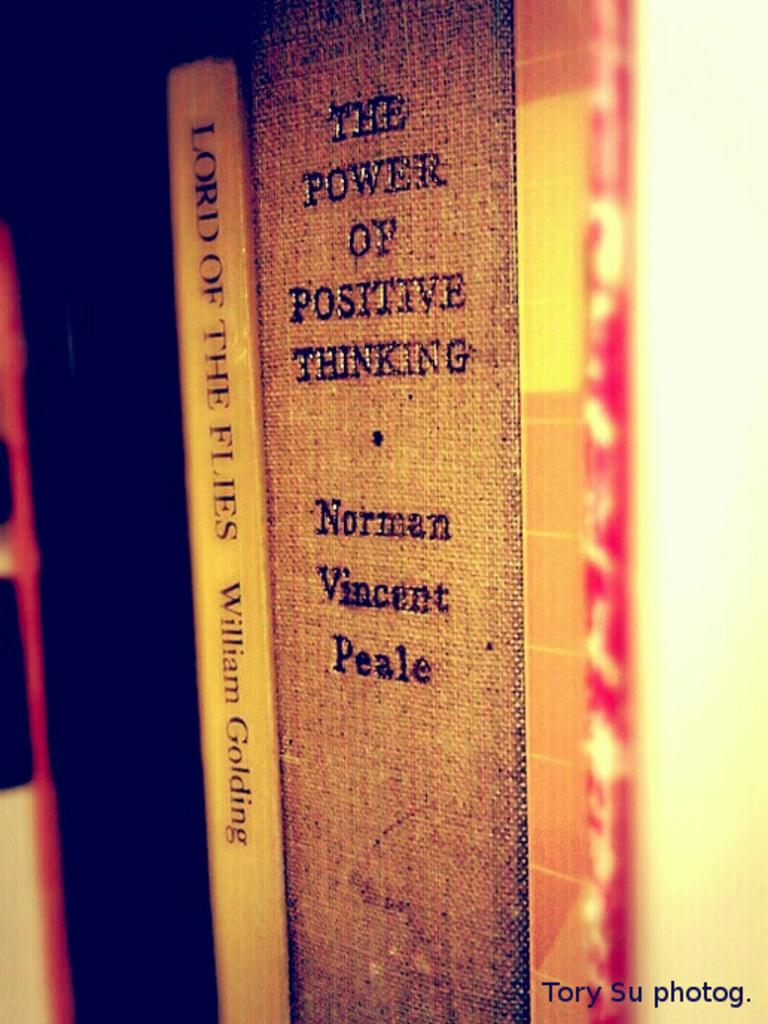<image>
Give a short and clear explanation of the subsequent image. Norman Vincent Peale's The power of Positive Thinking sits between other books on a shelf. 